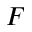<formula> <loc_0><loc_0><loc_500><loc_500>F</formula> 